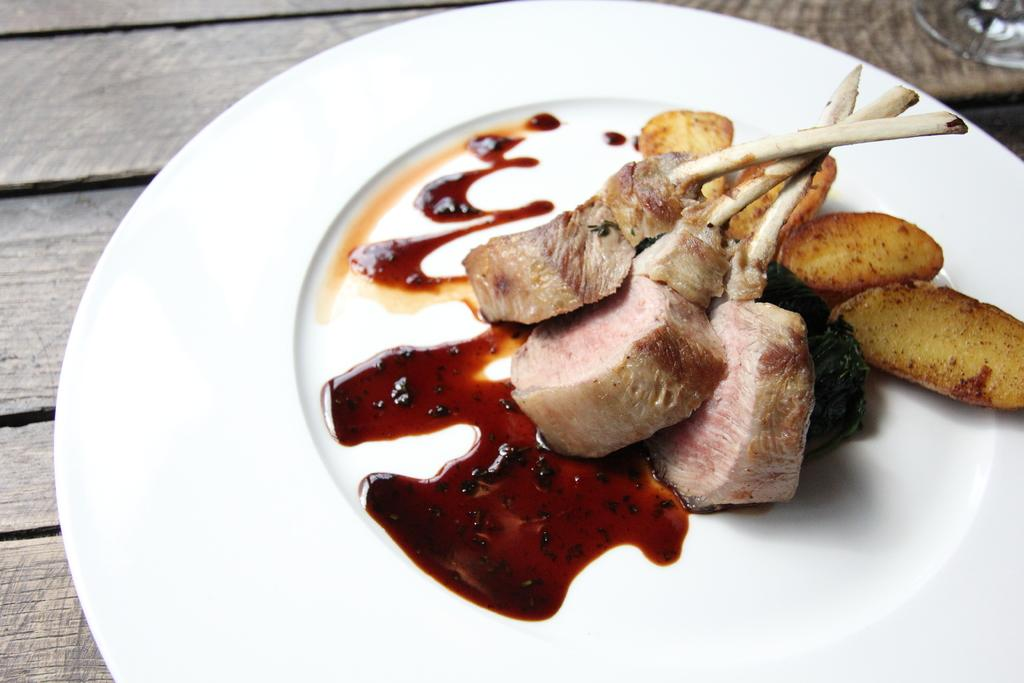What types of food items can be seen in the image? There are food items in the image, but the specific types cannot be determined without more information. What is on the white plate in the image? There is sauce on a white plate in the image. What is the surface beneath the white plate made of? The white plate is placed on a wooden surface. Where is the glass located in the image? The glass is in the right side top corner of the image. What type of cloud can be seen in the image? There are no clouds present in the image; it features food items, a white plate with sauce, a wooden surface, and a glass. What religious activity is taking place in the image? There is no religious activity or church depicted in the image. 